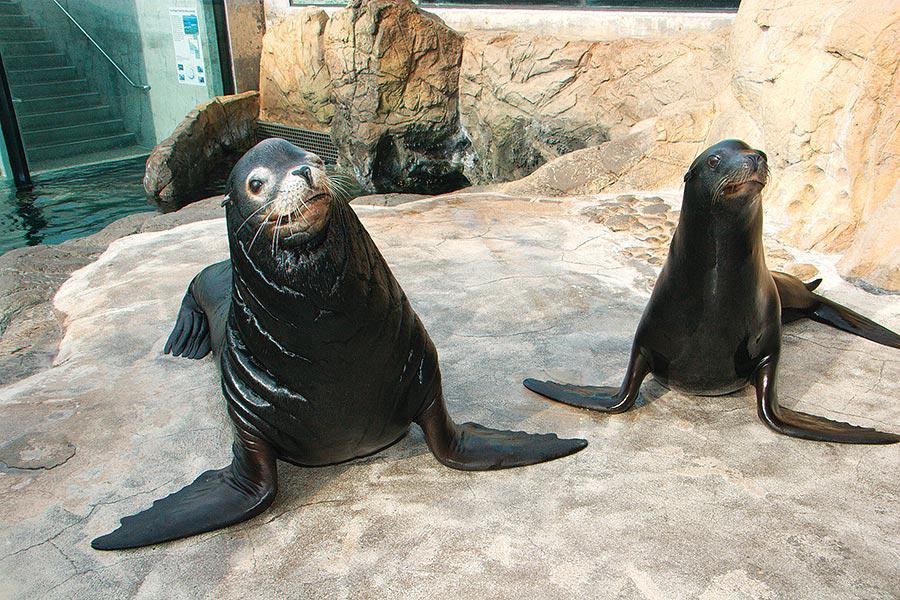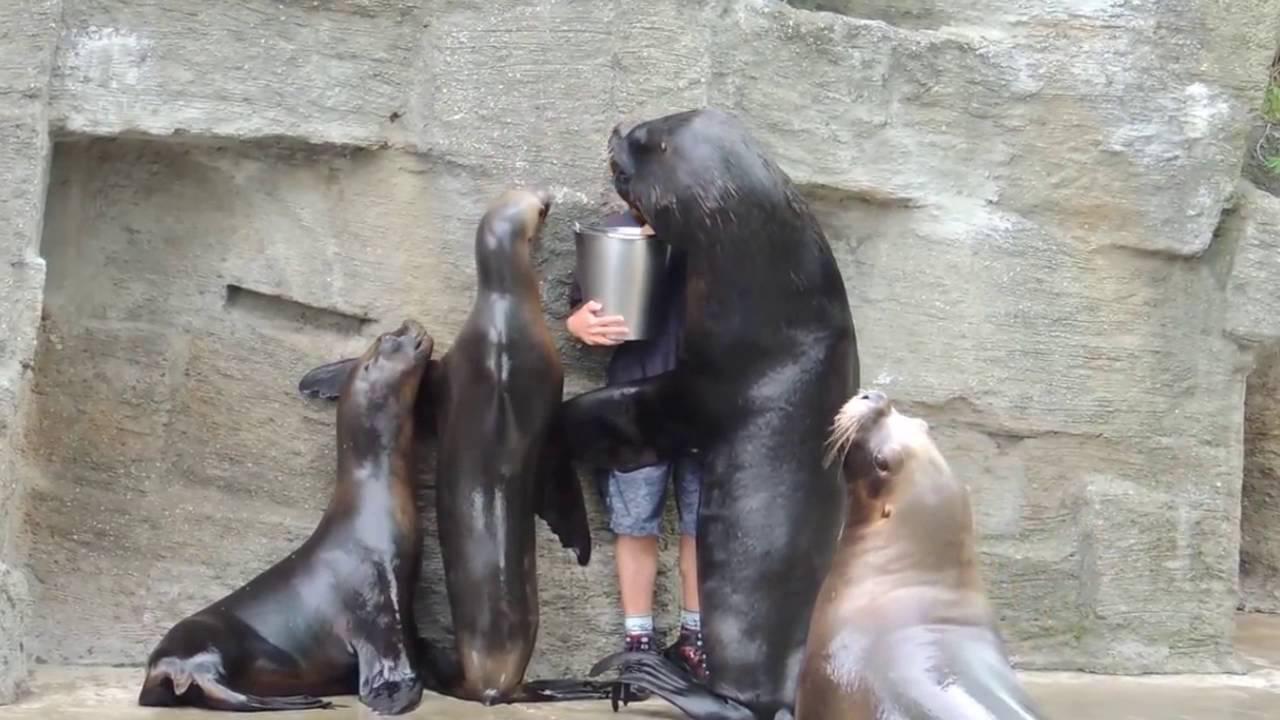The first image is the image on the left, the second image is the image on the right. Evaluate the accuracy of this statement regarding the images: "A man is holding a silver bucket as at least 3 seals gather around him.". Is it true? Answer yes or no. Yes. The first image is the image on the left, the second image is the image on the right. Considering the images on both sides, is "In both images, an aquarist is being hugged and kissed by a sea lion." valid? Answer yes or no. No. 